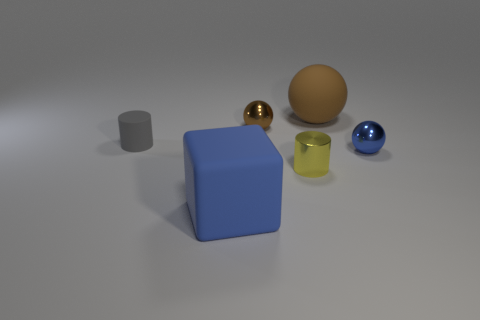Is the gray rubber object the same shape as the blue matte thing?
Ensure brevity in your answer.  No. There is a metallic ball that is behind the tiny cylinder on the left side of the big blue cube; how big is it?
Give a very brief answer. Small. What color is the other rubber object that is the same shape as the small yellow object?
Provide a short and direct response. Gray. How many small metallic balls have the same color as the big sphere?
Keep it short and to the point. 1. The brown metal object is what size?
Offer a very short reply. Small. Do the gray matte object and the blue sphere have the same size?
Ensure brevity in your answer.  Yes. What is the color of the thing that is both behind the gray cylinder and on the left side of the big brown ball?
Your answer should be very brief. Brown. What number of big brown objects are made of the same material as the big sphere?
Make the answer very short. 0. How many red shiny spheres are there?
Offer a very short reply. 0. There is a yellow cylinder; does it have the same size as the rubber object that is behind the tiny gray cylinder?
Keep it short and to the point. No. 